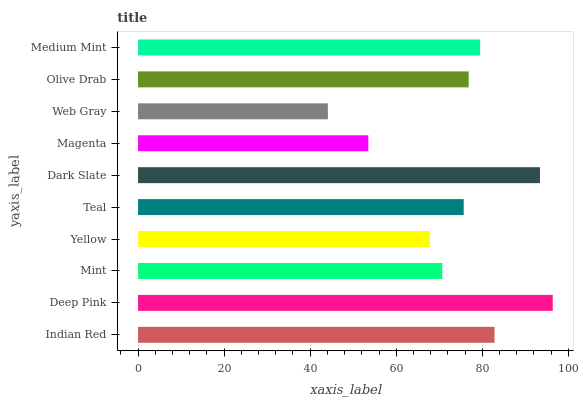Is Web Gray the minimum?
Answer yes or no. Yes. Is Deep Pink the maximum?
Answer yes or no. Yes. Is Mint the minimum?
Answer yes or no. No. Is Mint the maximum?
Answer yes or no. No. Is Deep Pink greater than Mint?
Answer yes or no. Yes. Is Mint less than Deep Pink?
Answer yes or no. Yes. Is Mint greater than Deep Pink?
Answer yes or no. No. Is Deep Pink less than Mint?
Answer yes or no. No. Is Olive Drab the high median?
Answer yes or no. Yes. Is Teal the low median?
Answer yes or no. Yes. Is Magenta the high median?
Answer yes or no. No. Is Indian Red the low median?
Answer yes or no. No. 